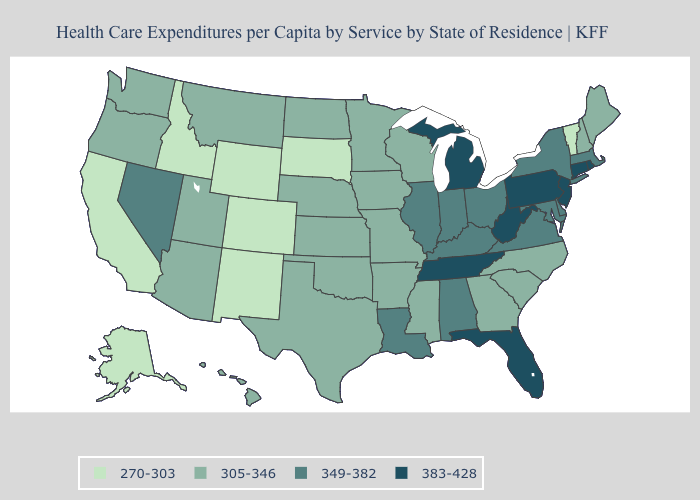Name the states that have a value in the range 383-428?
Concise answer only. Connecticut, Florida, Michigan, New Jersey, Pennsylvania, Rhode Island, Tennessee, West Virginia. What is the highest value in states that border Ohio?
Be succinct. 383-428. What is the highest value in states that border California?
Quick response, please. 349-382. Name the states that have a value in the range 270-303?
Keep it brief. Alaska, California, Colorado, Idaho, New Mexico, South Dakota, Vermont, Wyoming. What is the lowest value in the Northeast?
Write a very short answer. 270-303. Does Hawaii have the lowest value in the USA?
Be succinct. No. What is the lowest value in the USA?
Give a very brief answer. 270-303. What is the value of Utah?
Be succinct. 305-346. What is the lowest value in the MidWest?
Short answer required. 270-303. Does Pennsylvania have a higher value than Louisiana?
Write a very short answer. Yes. What is the highest value in the West ?
Concise answer only. 349-382. What is the highest value in states that border Maryland?
Concise answer only. 383-428. What is the value of Minnesota?
Concise answer only. 305-346. What is the value of Colorado?
Short answer required. 270-303. Name the states that have a value in the range 305-346?
Keep it brief. Arizona, Arkansas, Georgia, Hawaii, Iowa, Kansas, Maine, Minnesota, Mississippi, Missouri, Montana, Nebraska, New Hampshire, North Carolina, North Dakota, Oklahoma, Oregon, South Carolina, Texas, Utah, Washington, Wisconsin. 